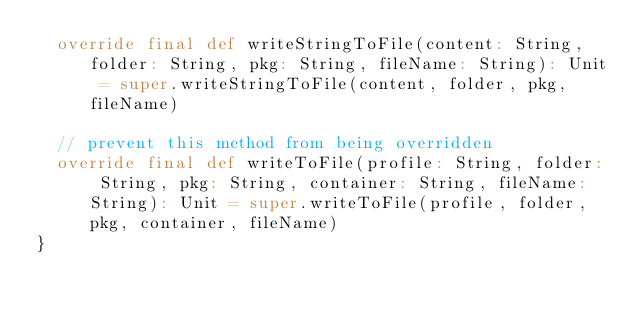Convert code to text. <code><loc_0><loc_0><loc_500><loc_500><_Scala_>  override final def writeStringToFile(content: String, folder: String, pkg: String, fileName: String): Unit = super.writeStringToFile(content, folder, pkg, fileName)

  // prevent this method from being overridden
  override final def writeToFile(profile: String, folder: String, pkg: String, container: String, fileName: String): Unit = super.writeToFile(profile, folder, pkg, container, fileName)
}
</code> 